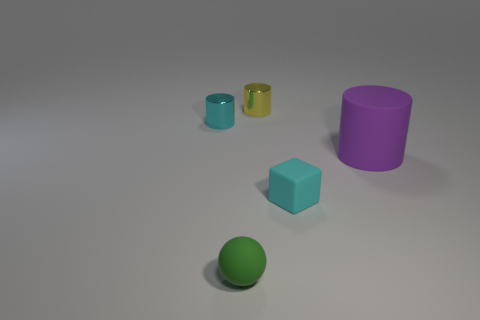Add 2 red matte spheres. How many objects exist? 7 Subtract all cylinders. How many objects are left? 2 Subtract 0 red balls. How many objects are left? 5 Subtract all cubes. Subtract all small cyan shiny things. How many objects are left? 3 Add 5 tiny yellow objects. How many tiny yellow objects are left? 6 Add 5 cyan cylinders. How many cyan cylinders exist? 6 